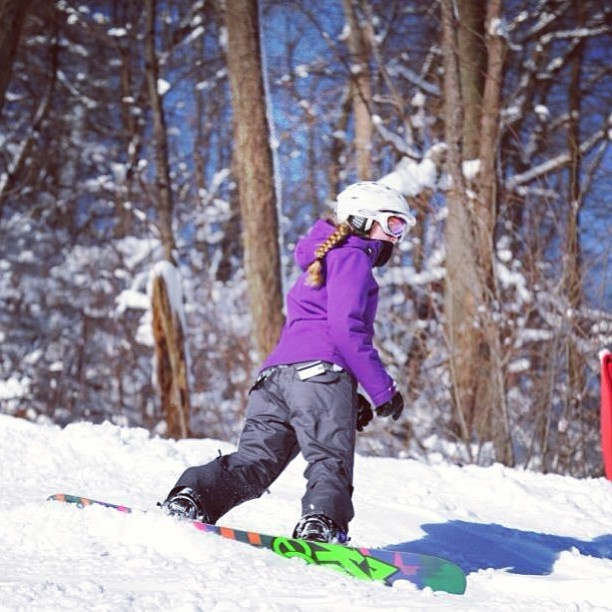Describe the objects in this image and their specific colors. I can see people in black, white, darkgray, gray, and magenta tones and snowboard in black, white, teal, gray, and lime tones in this image. 